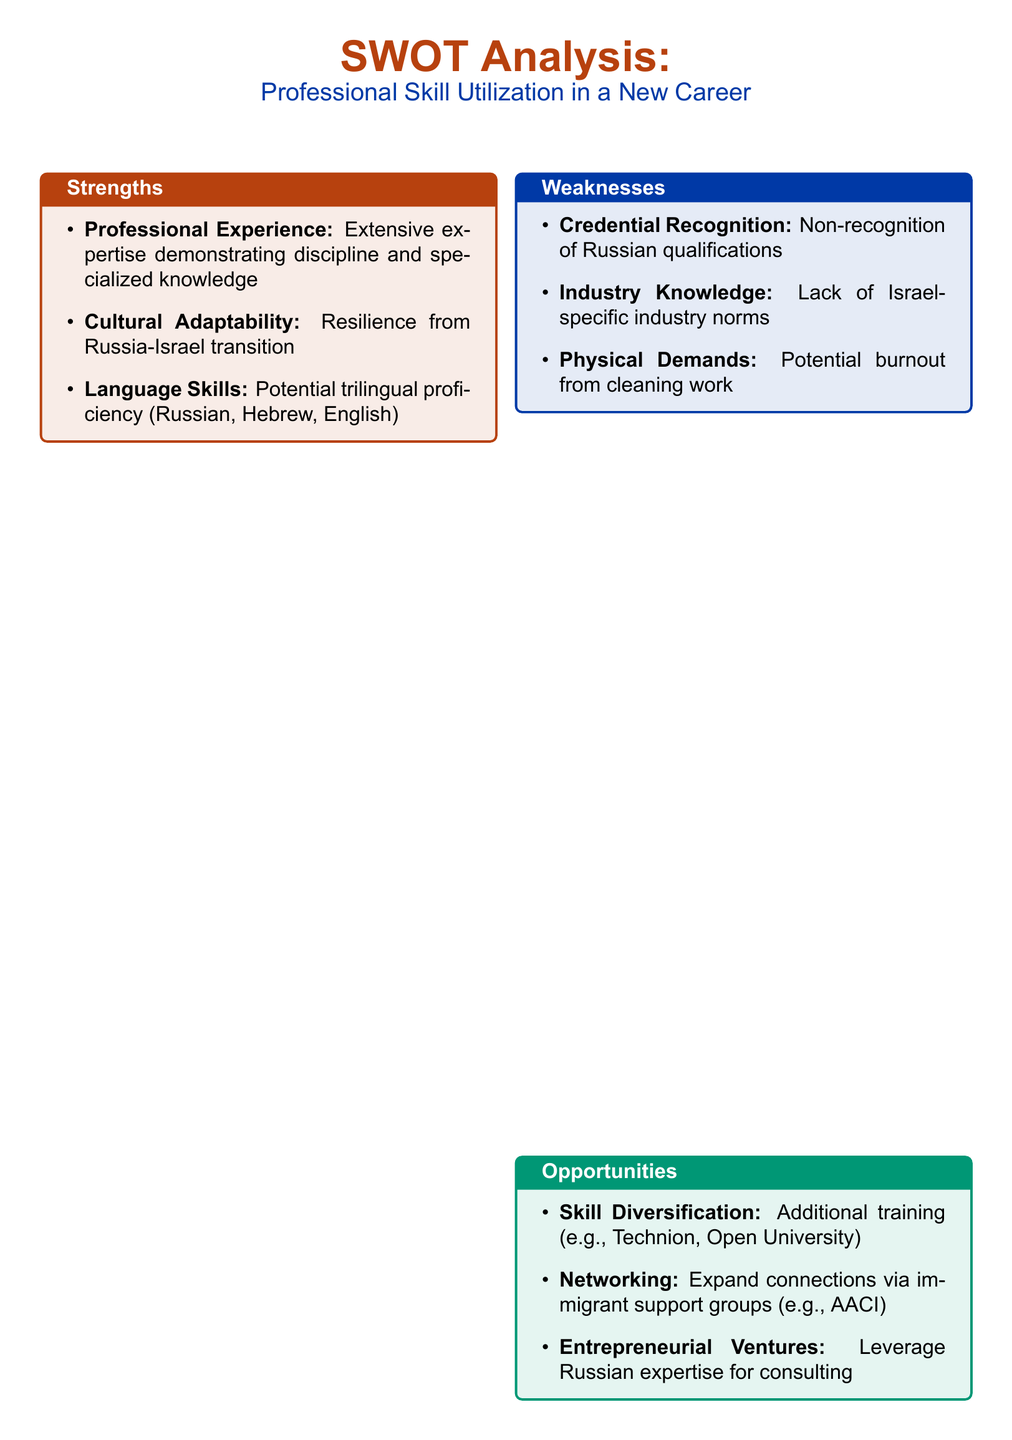What is the title of the document? The title at the top of the document indicates the focus of the SWOT analysis, which is "Professional Skill Utilization in a New Career."
Answer: Professional Skill Utilization in a New Career How many areas are covered in the SWOT analysis? The document includes four distinct areas, as denoted by the four labeled sections: Strengths, Weaknesses, Opportunities, and Threats.
Answer: Four What is a strength related to language skills? The document lists "Potential trilingual proficiency" under the Strengths section regarding language skills.
Answer: Potential trilingual proficiency Which organization is mentioned for networking opportunities? The document references "AACI" as a group where one can expand connections.
Answer: AACI What is one identified weakness regarding credentials? The document highlights "Non-recognition of Russian qualifications" as a weakness.
Answer: Non-recognition of Russian qualifications What type of economic factor is listed as a threat? The document notes "Economic Instability" as a threat affecting job security.
Answer: Economic Instability What is one of the opportunities for skill utilization mentioned? The document states "Additional training (e.g., Technion, Open University)" as an opportunity for skill diversification.
Answer: Additional training (e.g., Technion, Open University) Which color is used for the Strengths section? The Strengths section utilizes the color rust red, as specified in the formatting of the document.
Answer: Rust red 